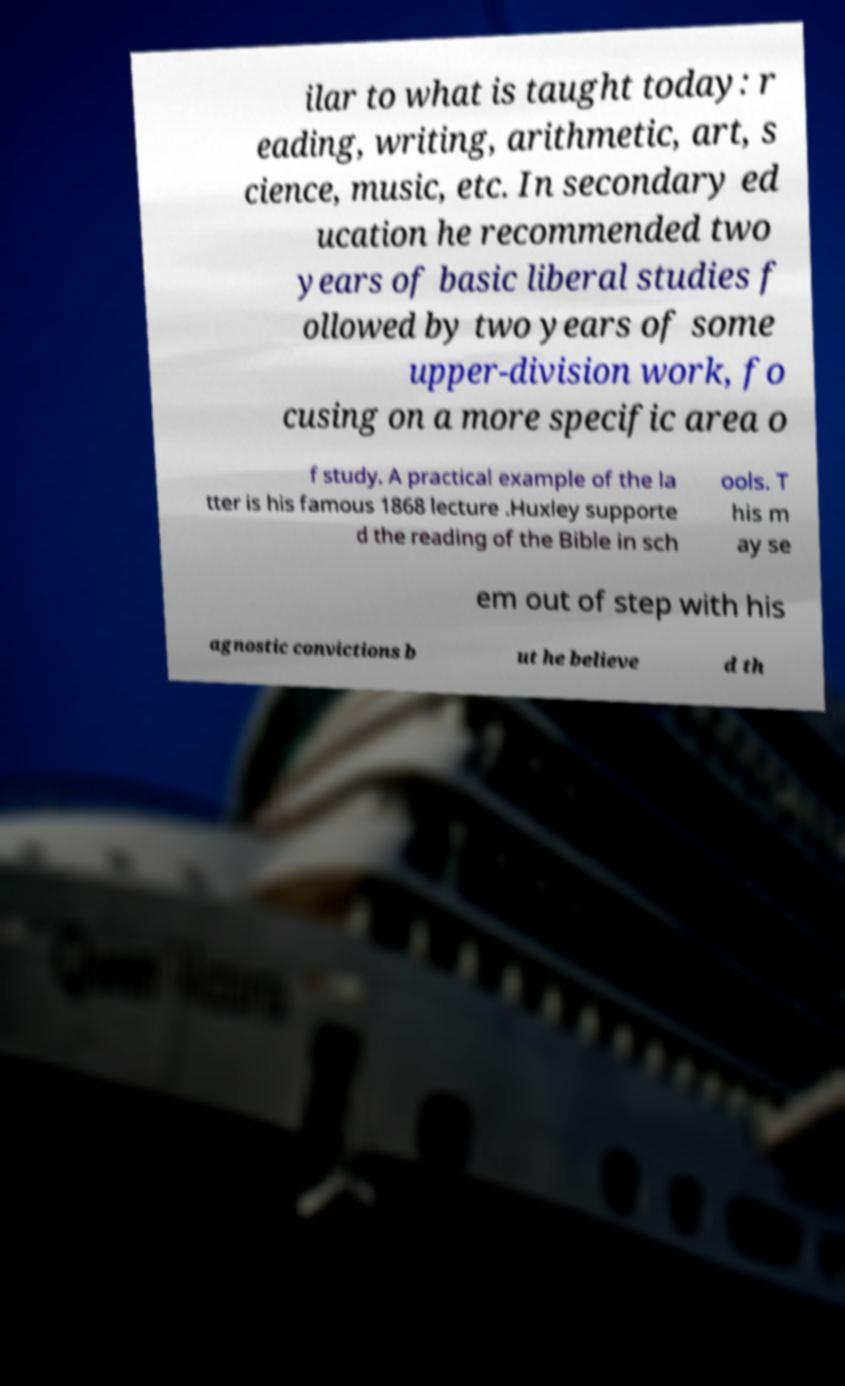Please identify and transcribe the text found in this image. ilar to what is taught today: r eading, writing, arithmetic, art, s cience, music, etc. In secondary ed ucation he recommended two years of basic liberal studies f ollowed by two years of some upper-division work, fo cusing on a more specific area o f study. A practical example of the la tter is his famous 1868 lecture .Huxley supporte d the reading of the Bible in sch ools. T his m ay se em out of step with his agnostic convictions b ut he believe d th 